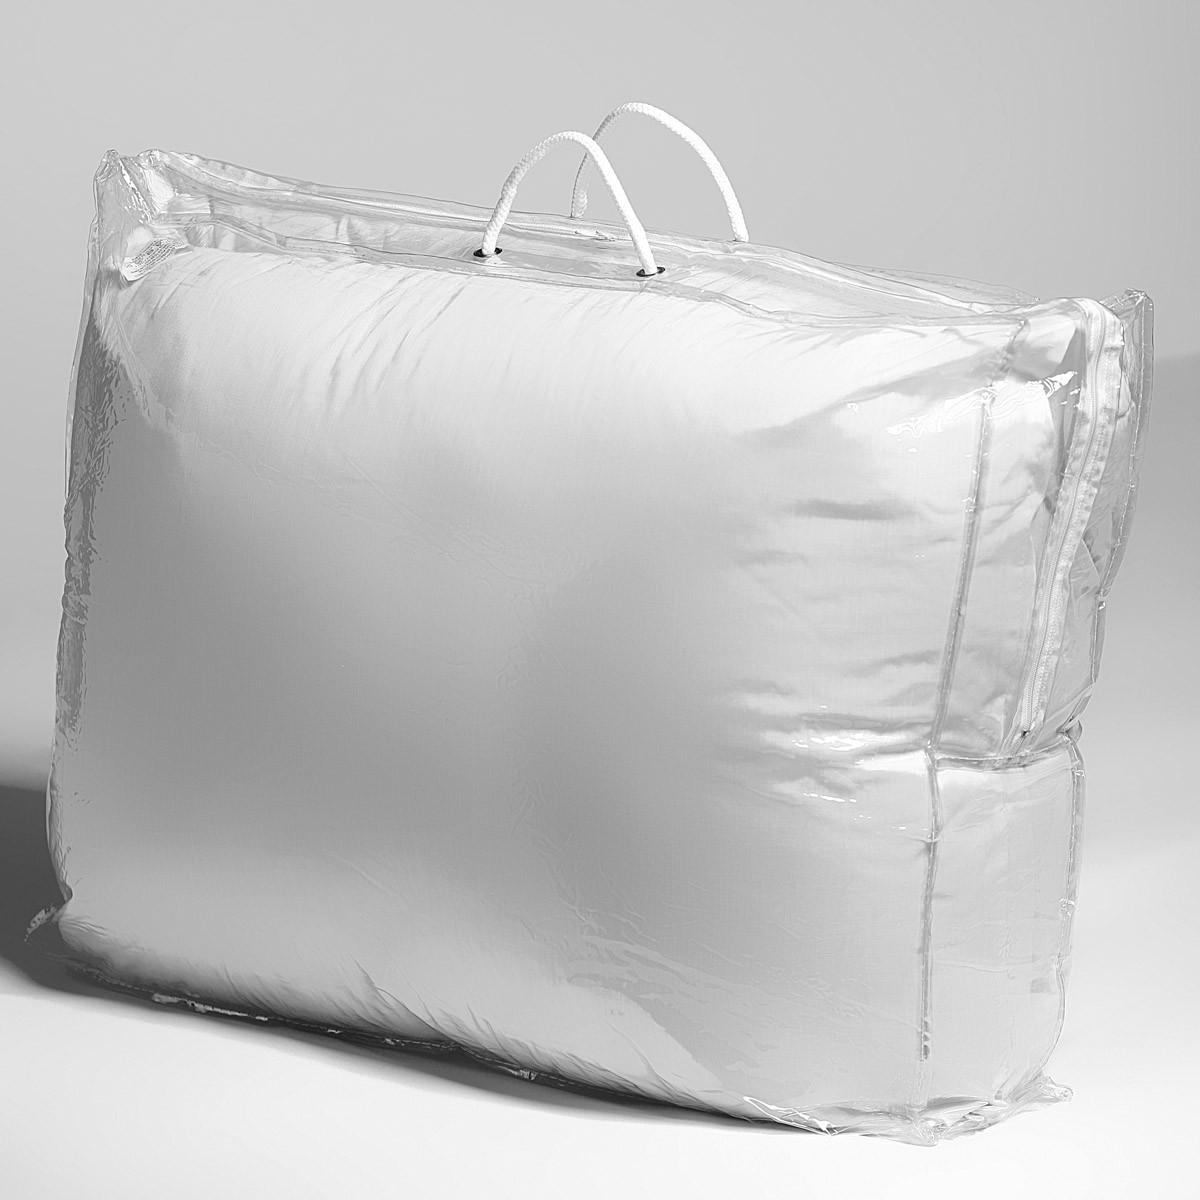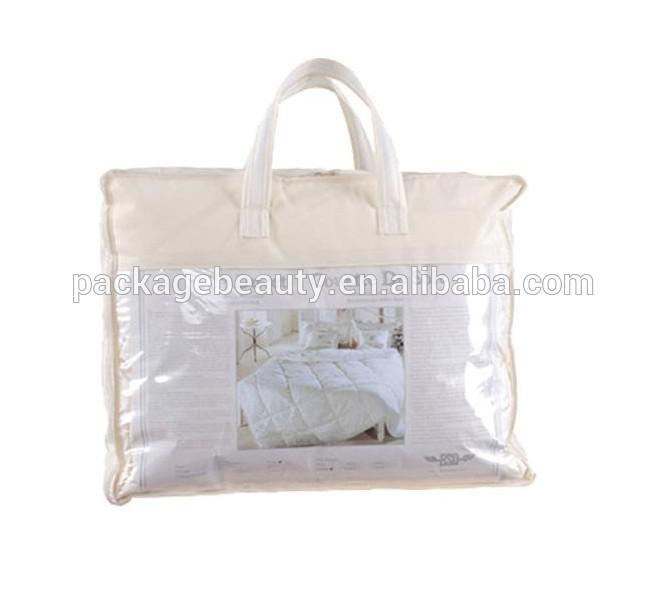The first image is the image on the left, the second image is the image on the right. Assess this claim about the two images: "The left image contains a handled pillow shape with black text printed on its front, and the right image features a pillow with no handle.". Correct or not? Answer yes or no. No. 